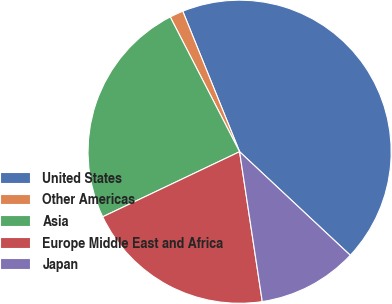<chart> <loc_0><loc_0><loc_500><loc_500><pie_chart><fcel>United States<fcel>Other Americas<fcel>Asia<fcel>Europe Middle East and Africa<fcel>Japan<nl><fcel>43.09%<fcel>1.45%<fcel>24.5%<fcel>20.33%<fcel>10.64%<nl></chart> 